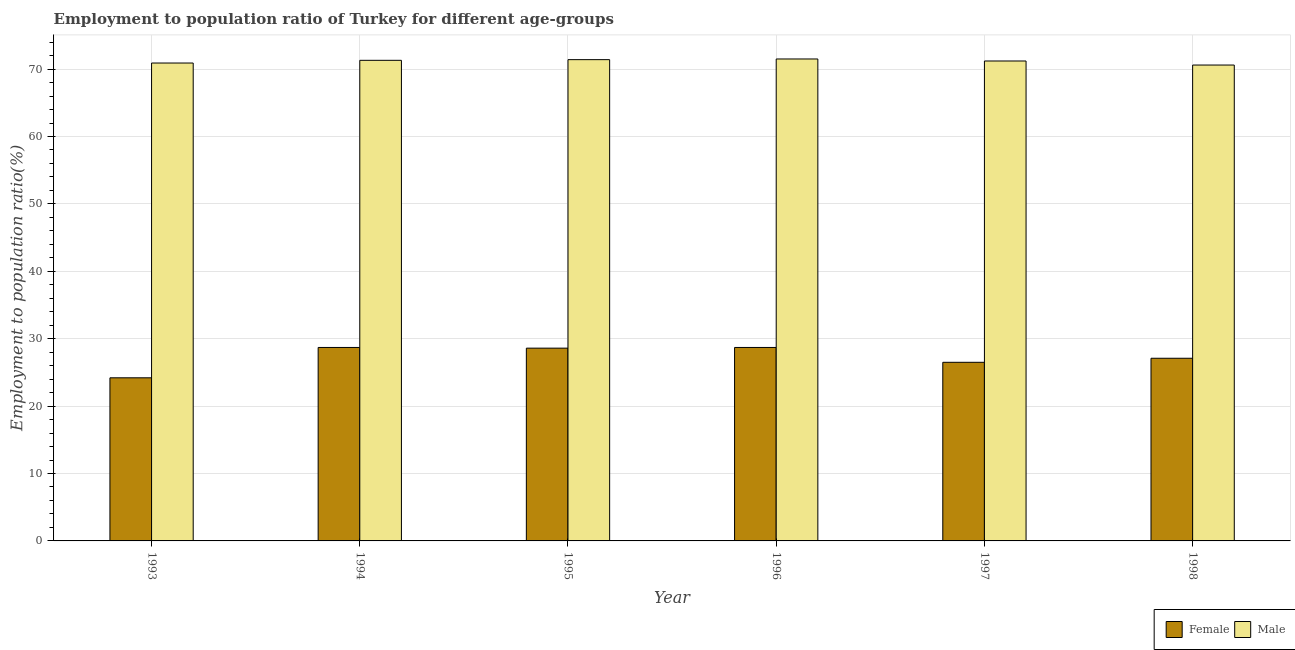How many different coloured bars are there?
Your response must be concise. 2. Are the number of bars per tick equal to the number of legend labels?
Offer a terse response. Yes. How many bars are there on the 1st tick from the left?
Offer a terse response. 2. What is the employment to population ratio(female) in 1994?
Provide a short and direct response. 28.7. Across all years, what is the maximum employment to population ratio(male)?
Your answer should be very brief. 71.5. Across all years, what is the minimum employment to population ratio(female)?
Give a very brief answer. 24.2. In which year was the employment to population ratio(male) minimum?
Make the answer very short. 1998. What is the total employment to population ratio(female) in the graph?
Give a very brief answer. 163.8. What is the difference between the employment to population ratio(female) in 1995 and that in 1998?
Give a very brief answer. 1.5. What is the difference between the employment to population ratio(female) in 1994 and the employment to population ratio(male) in 1997?
Your answer should be compact. 2.2. What is the average employment to population ratio(female) per year?
Keep it short and to the point. 27.3. In the year 1998, what is the difference between the employment to population ratio(female) and employment to population ratio(male)?
Offer a terse response. 0. In how many years, is the employment to population ratio(male) greater than 20 %?
Your answer should be very brief. 6. What is the ratio of the employment to population ratio(female) in 1993 to that in 1998?
Offer a very short reply. 0.89. Is the employment to population ratio(female) in 1994 less than that in 1996?
Provide a succinct answer. No. Is the difference between the employment to population ratio(female) in 1996 and 1998 greater than the difference between the employment to population ratio(male) in 1996 and 1998?
Ensure brevity in your answer.  No. What is the difference between the highest and the second highest employment to population ratio(male)?
Your response must be concise. 0.1. What is the difference between the highest and the lowest employment to population ratio(male)?
Ensure brevity in your answer.  0.9. In how many years, is the employment to population ratio(male) greater than the average employment to population ratio(male) taken over all years?
Ensure brevity in your answer.  4. Is the sum of the employment to population ratio(male) in 1993 and 1994 greater than the maximum employment to population ratio(female) across all years?
Offer a terse response. Yes. What does the 1st bar from the right in 1996 represents?
Provide a succinct answer. Male. Are all the bars in the graph horizontal?
Provide a short and direct response. No. Does the graph contain grids?
Keep it short and to the point. Yes. Where does the legend appear in the graph?
Keep it short and to the point. Bottom right. What is the title of the graph?
Ensure brevity in your answer.  Employment to population ratio of Turkey for different age-groups. Does "Commercial bank branches" appear as one of the legend labels in the graph?
Ensure brevity in your answer.  No. What is the label or title of the Y-axis?
Your answer should be very brief. Employment to population ratio(%). What is the Employment to population ratio(%) in Female in 1993?
Give a very brief answer. 24.2. What is the Employment to population ratio(%) of Male in 1993?
Provide a succinct answer. 70.9. What is the Employment to population ratio(%) in Female in 1994?
Offer a very short reply. 28.7. What is the Employment to population ratio(%) in Male in 1994?
Make the answer very short. 71.3. What is the Employment to population ratio(%) of Female in 1995?
Your answer should be compact. 28.6. What is the Employment to population ratio(%) in Male in 1995?
Ensure brevity in your answer.  71.4. What is the Employment to population ratio(%) of Female in 1996?
Keep it short and to the point. 28.7. What is the Employment to population ratio(%) of Male in 1996?
Ensure brevity in your answer.  71.5. What is the Employment to population ratio(%) of Female in 1997?
Your answer should be very brief. 26.5. What is the Employment to population ratio(%) of Male in 1997?
Your answer should be very brief. 71.2. What is the Employment to population ratio(%) in Female in 1998?
Provide a succinct answer. 27.1. What is the Employment to population ratio(%) of Male in 1998?
Ensure brevity in your answer.  70.6. Across all years, what is the maximum Employment to population ratio(%) of Female?
Offer a very short reply. 28.7. Across all years, what is the maximum Employment to population ratio(%) of Male?
Give a very brief answer. 71.5. Across all years, what is the minimum Employment to population ratio(%) in Female?
Offer a terse response. 24.2. Across all years, what is the minimum Employment to population ratio(%) of Male?
Give a very brief answer. 70.6. What is the total Employment to population ratio(%) of Female in the graph?
Provide a succinct answer. 163.8. What is the total Employment to population ratio(%) of Male in the graph?
Offer a very short reply. 426.9. What is the difference between the Employment to population ratio(%) of Female in 1993 and that in 1995?
Ensure brevity in your answer.  -4.4. What is the difference between the Employment to population ratio(%) of Male in 1993 and that in 1995?
Provide a short and direct response. -0.5. What is the difference between the Employment to population ratio(%) in Male in 1993 and that in 1996?
Give a very brief answer. -0.6. What is the difference between the Employment to population ratio(%) in Female in 1994 and that in 1997?
Your answer should be compact. 2.2. What is the difference between the Employment to population ratio(%) in Male in 1994 and that in 1997?
Ensure brevity in your answer.  0.1. What is the difference between the Employment to population ratio(%) in Female in 1994 and that in 1998?
Provide a short and direct response. 1.6. What is the difference between the Employment to population ratio(%) in Female in 1995 and that in 1996?
Your response must be concise. -0.1. What is the difference between the Employment to population ratio(%) in Male in 1995 and that in 1996?
Offer a terse response. -0.1. What is the difference between the Employment to population ratio(%) in Female in 1995 and that in 1998?
Give a very brief answer. 1.5. What is the difference between the Employment to population ratio(%) in Male in 1995 and that in 1998?
Provide a succinct answer. 0.8. What is the difference between the Employment to population ratio(%) in Female in 1996 and that in 1997?
Provide a succinct answer. 2.2. What is the difference between the Employment to population ratio(%) of Female in 1996 and that in 1998?
Keep it short and to the point. 1.6. What is the difference between the Employment to population ratio(%) of Male in 1996 and that in 1998?
Your answer should be very brief. 0.9. What is the difference between the Employment to population ratio(%) in Male in 1997 and that in 1998?
Ensure brevity in your answer.  0.6. What is the difference between the Employment to population ratio(%) in Female in 1993 and the Employment to population ratio(%) in Male in 1994?
Ensure brevity in your answer.  -47.1. What is the difference between the Employment to population ratio(%) in Female in 1993 and the Employment to population ratio(%) in Male in 1995?
Keep it short and to the point. -47.2. What is the difference between the Employment to population ratio(%) of Female in 1993 and the Employment to population ratio(%) of Male in 1996?
Your answer should be very brief. -47.3. What is the difference between the Employment to population ratio(%) in Female in 1993 and the Employment to population ratio(%) in Male in 1997?
Offer a terse response. -47. What is the difference between the Employment to population ratio(%) in Female in 1993 and the Employment to population ratio(%) in Male in 1998?
Keep it short and to the point. -46.4. What is the difference between the Employment to population ratio(%) in Female in 1994 and the Employment to population ratio(%) in Male in 1995?
Give a very brief answer. -42.7. What is the difference between the Employment to population ratio(%) in Female in 1994 and the Employment to population ratio(%) in Male in 1996?
Provide a succinct answer. -42.8. What is the difference between the Employment to population ratio(%) of Female in 1994 and the Employment to population ratio(%) of Male in 1997?
Provide a succinct answer. -42.5. What is the difference between the Employment to population ratio(%) of Female in 1994 and the Employment to population ratio(%) of Male in 1998?
Make the answer very short. -41.9. What is the difference between the Employment to population ratio(%) of Female in 1995 and the Employment to population ratio(%) of Male in 1996?
Your answer should be very brief. -42.9. What is the difference between the Employment to population ratio(%) in Female in 1995 and the Employment to population ratio(%) in Male in 1997?
Your response must be concise. -42.6. What is the difference between the Employment to population ratio(%) in Female in 1995 and the Employment to population ratio(%) in Male in 1998?
Keep it short and to the point. -42. What is the difference between the Employment to population ratio(%) in Female in 1996 and the Employment to population ratio(%) in Male in 1997?
Ensure brevity in your answer.  -42.5. What is the difference between the Employment to population ratio(%) in Female in 1996 and the Employment to population ratio(%) in Male in 1998?
Keep it short and to the point. -41.9. What is the difference between the Employment to population ratio(%) in Female in 1997 and the Employment to population ratio(%) in Male in 1998?
Give a very brief answer. -44.1. What is the average Employment to population ratio(%) in Female per year?
Make the answer very short. 27.3. What is the average Employment to population ratio(%) of Male per year?
Give a very brief answer. 71.15. In the year 1993, what is the difference between the Employment to population ratio(%) of Female and Employment to population ratio(%) of Male?
Ensure brevity in your answer.  -46.7. In the year 1994, what is the difference between the Employment to population ratio(%) of Female and Employment to population ratio(%) of Male?
Give a very brief answer. -42.6. In the year 1995, what is the difference between the Employment to population ratio(%) of Female and Employment to population ratio(%) of Male?
Provide a succinct answer. -42.8. In the year 1996, what is the difference between the Employment to population ratio(%) in Female and Employment to population ratio(%) in Male?
Keep it short and to the point. -42.8. In the year 1997, what is the difference between the Employment to population ratio(%) of Female and Employment to population ratio(%) of Male?
Your answer should be compact. -44.7. In the year 1998, what is the difference between the Employment to population ratio(%) in Female and Employment to population ratio(%) in Male?
Your response must be concise. -43.5. What is the ratio of the Employment to population ratio(%) of Female in 1993 to that in 1994?
Offer a very short reply. 0.84. What is the ratio of the Employment to population ratio(%) of Female in 1993 to that in 1995?
Provide a short and direct response. 0.85. What is the ratio of the Employment to population ratio(%) in Male in 1993 to that in 1995?
Your response must be concise. 0.99. What is the ratio of the Employment to population ratio(%) in Female in 1993 to that in 1996?
Give a very brief answer. 0.84. What is the ratio of the Employment to population ratio(%) in Male in 1993 to that in 1996?
Your answer should be very brief. 0.99. What is the ratio of the Employment to population ratio(%) in Female in 1993 to that in 1997?
Your answer should be very brief. 0.91. What is the ratio of the Employment to population ratio(%) of Male in 1993 to that in 1997?
Provide a succinct answer. 1. What is the ratio of the Employment to population ratio(%) of Female in 1993 to that in 1998?
Provide a succinct answer. 0.89. What is the ratio of the Employment to population ratio(%) in Male in 1993 to that in 1998?
Keep it short and to the point. 1. What is the ratio of the Employment to population ratio(%) of Male in 1994 to that in 1995?
Your answer should be very brief. 1. What is the ratio of the Employment to population ratio(%) in Female in 1994 to that in 1997?
Keep it short and to the point. 1.08. What is the ratio of the Employment to population ratio(%) in Female in 1994 to that in 1998?
Your answer should be compact. 1.06. What is the ratio of the Employment to population ratio(%) in Male in 1994 to that in 1998?
Keep it short and to the point. 1.01. What is the ratio of the Employment to population ratio(%) in Female in 1995 to that in 1996?
Keep it short and to the point. 1. What is the ratio of the Employment to population ratio(%) in Female in 1995 to that in 1997?
Provide a succinct answer. 1.08. What is the ratio of the Employment to population ratio(%) in Female in 1995 to that in 1998?
Provide a succinct answer. 1.06. What is the ratio of the Employment to population ratio(%) of Male in 1995 to that in 1998?
Provide a short and direct response. 1.01. What is the ratio of the Employment to population ratio(%) in Female in 1996 to that in 1997?
Provide a succinct answer. 1.08. What is the ratio of the Employment to population ratio(%) of Male in 1996 to that in 1997?
Offer a very short reply. 1. What is the ratio of the Employment to population ratio(%) of Female in 1996 to that in 1998?
Give a very brief answer. 1.06. What is the ratio of the Employment to population ratio(%) of Male in 1996 to that in 1998?
Ensure brevity in your answer.  1.01. What is the ratio of the Employment to population ratio(%) in Female in 1997 to that in 1998?
Ensure brevity in your answer.  0.98. What is the ratio of the Employment to population ratio(%) of Male in 1997 to that in 1998?
Make the answer very short. 1.01. What is the difference between the highest and the second highest Employment to population ratio(%) in Female?
Offer a terse response. 0. What is the difference between the highest and the lowest Employment to population ratio(%) in Male?
Provide a succinct answer. 0.9. 